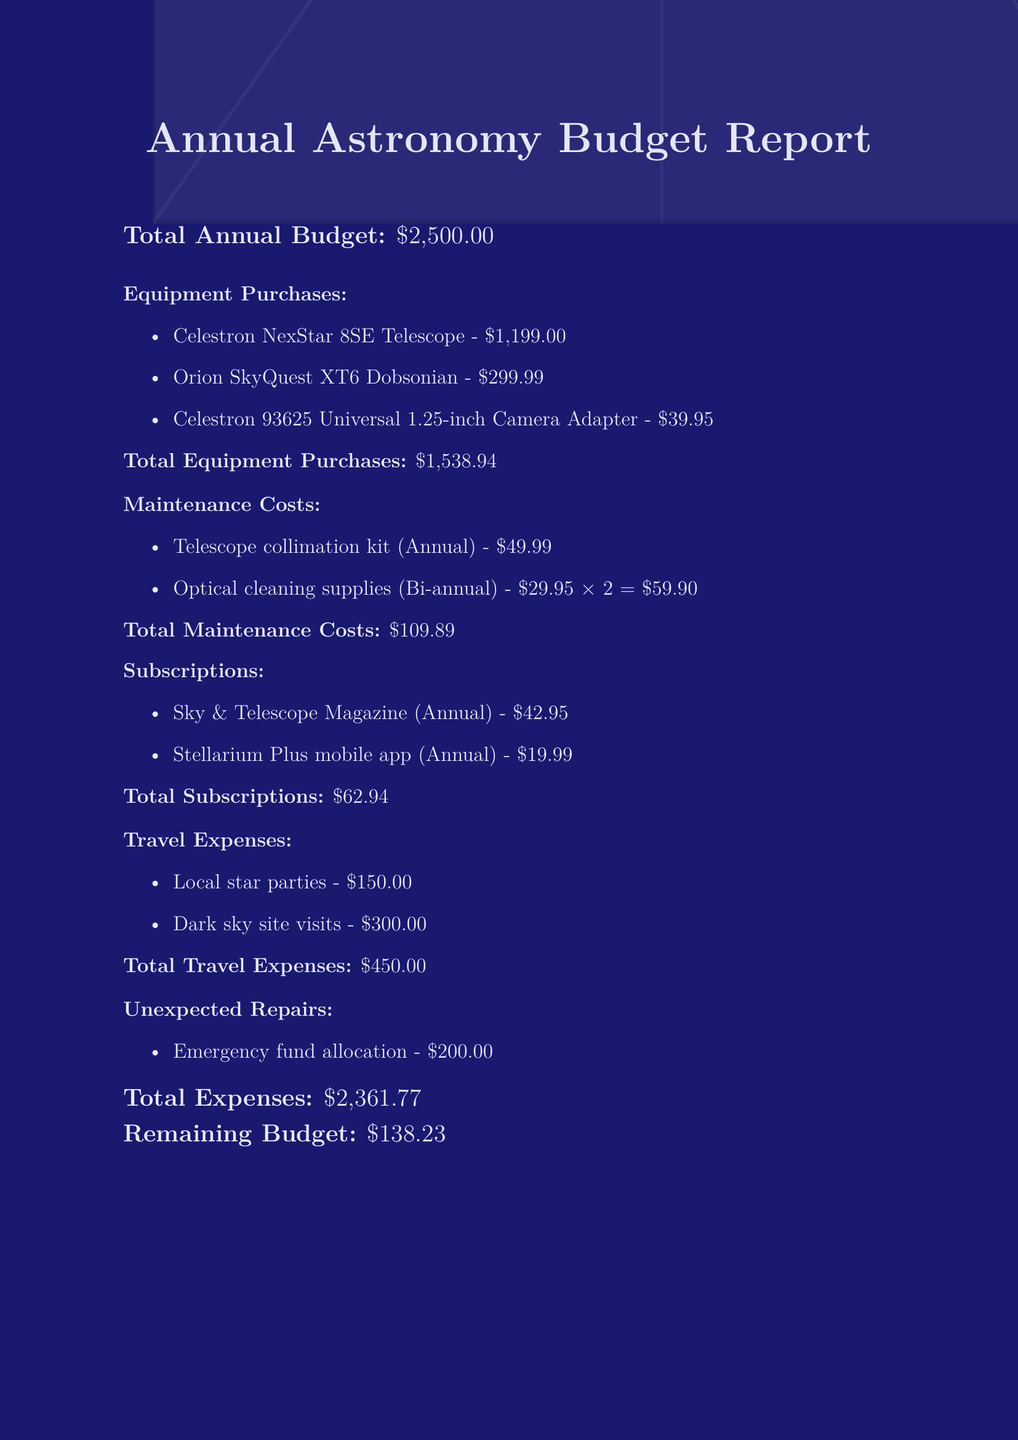What is the total annual budget? The total annual budget is stated clearly in the document.
Answer: $2,500.00 How much does the Celestron NexStar 8SE Telescope cost? The cost of the Celestron NexStar 8SE Telescope is explicitly listed as an equipment purchase.
Answer: $1,199.00 What is the cost for the annual subscription to Sky & Telescope Magazine? The document provides the cost of the Sky & Telescope Magazine subscription under the subscription section.
Answer: $42.95 What is the total cost allocated for unexpected repairs? The allocation for unexpected repairs is specified in the document.
Answer: $200.00 How much are the total maintenance costs? The total maintenance costs are calculated by summing individual maintenance items in the document.
Answer: $109.89 What is the cost for dark sky site visits? The document details the travel expenses including the cost for dark sky site visits.
Answer: $300.00 What is the remaining budget after all expenses? The remaining budget is derived from the total budget minus total expenses mentioned in the document.
Answer: $138.23 How many pieces of equipment were purchased in total? The document lists the number of equipment purchases made, emphasizing the total count.
Answer: 3 How often do the optical cleaning supplies need to be purchased? The frequency of purchasing optical cleaning supplies is mentioned under maintenance costs.
Answer: Bi-annual 